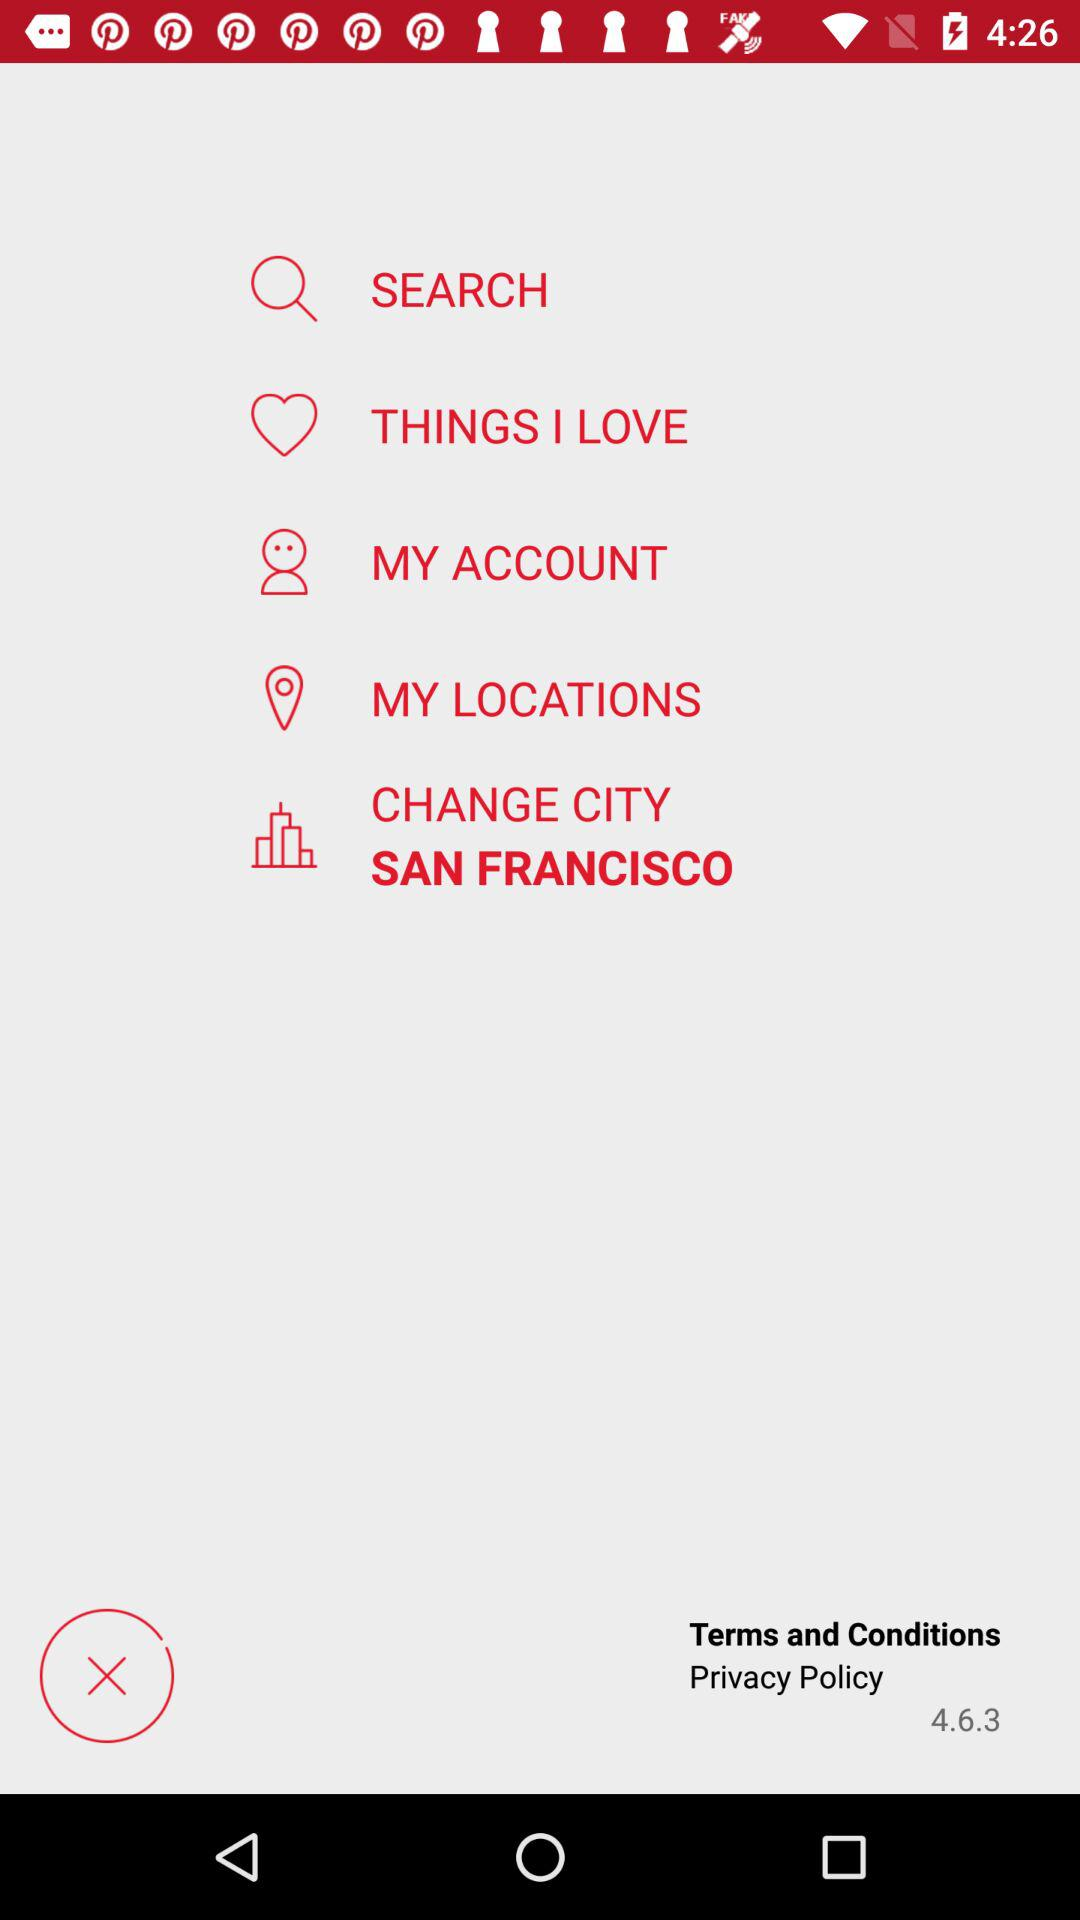In which city is Español used? Español is used in Ciudad de México. 